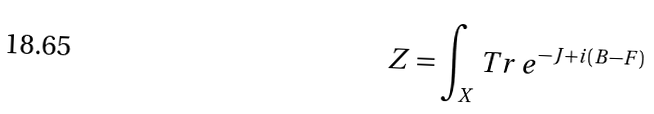Convert formula to latex. <formula><loc_0><loc_0><loc_500><loc_500>Z = \int _ { X } T r \, e ^ { - J + i ( B - F ) }</formula> 